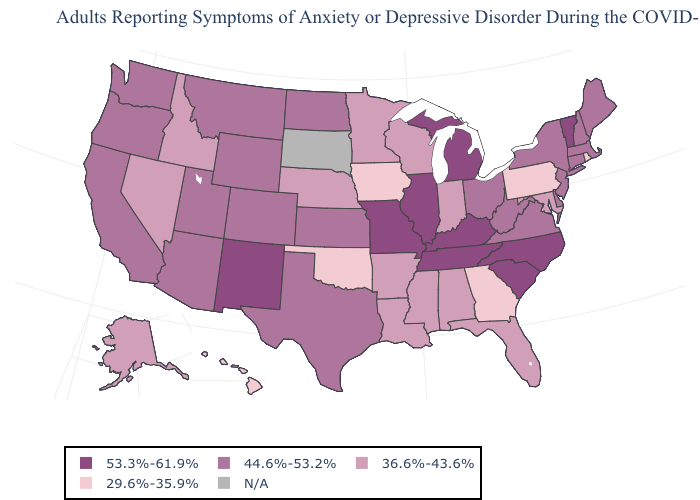Among the states that border Oklahoma , does Texas have the highest value?
Short answer required. No. What is the lowest value in the USA?
Keep it brief. 29.6%-35.9%. Does the map have missing data?
Give a very brief answer. Yes. Which states have the lowest value in the West?
Be succinct. Hawaii. Does New York have the highest value in the Northeast?
Concise answer only. No. What is the lowest value in states that border Mississippi?
Short answer required. 36.6%-43.6%. How many symbols are there in the legend?
Short answer required. 5. Which states hav the highest value in the Northeast?
Be succinct. Vermont. Name the states that have a value in the range N/A?
Concise answer only. South Dakota. Does Nevada have the lowest value in the USA?
Keep it brief. No. What is the value of New Hampshire?
Write a very short answer. 44.6%-53.2%. Does the map have missing data?
Short answer required. Yes. Among the states that border Colorado , does Oklahoma have the lowest value?
Short answer required. Yes. Which states have the lowest value in the USA?
Keep it brief. Georgia, Hawaii, Iowa, Oklahoma, Pennsylvania, Rhode Island. Does the first symbol in the legend represent the smallest category?
Answer briefly. No. 